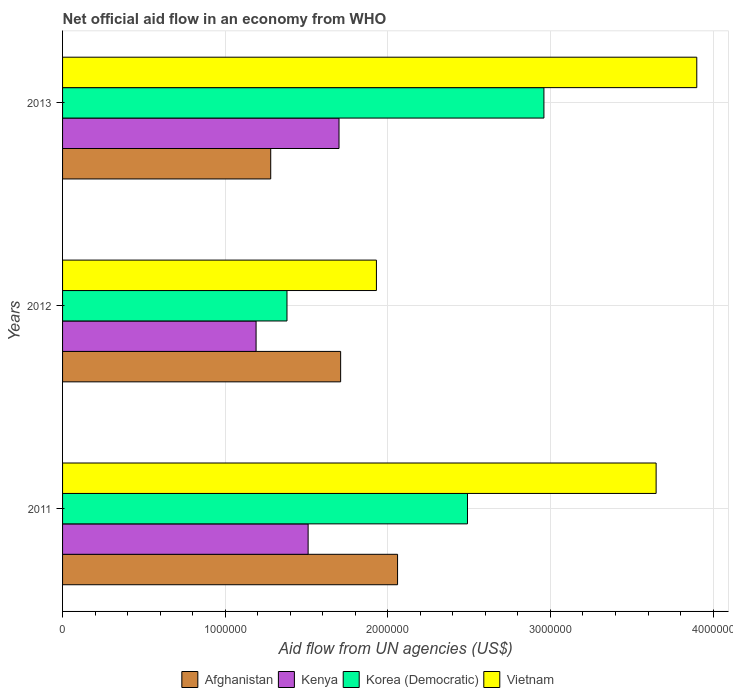How many groups of bars are there?
Make the answer very short. 3. In how many cases, is the number of bars for a given year not equal to the number of legend labels?
Give a very brief answer. 0. What is the net official aid flow in Kenya in 2013?
Offer a terse response. 1.70e+06. Across all years, what is the maximum net official aid flow in Korea (Democratic)?
Your response must be concise. 2.96e+06. Across all years, what is the minimum net official aid flow in Afghanistan?
Your answer should be very brief. 1.28e+06. What is the total net official aid flow in Korea (Democratic) in the graph?
Give a very brief answer. 6.83e+06. What is the difference between the net official aid flow in Korea (Democratic) in 2011 and the net official aid flow in Afghanistan in 2013?
Keep it short and to the point. 1.21e+06. What is the average net official aid flow in Kenya per year?
Ensure brevity in your answer.  1.47e+06. In the year 2013, what is the difference between the net official aid flow in Vietnam and net official aid flow in Kenya?
Offer a terse response. 2.20e+06. In how many years, is the net official aid flow in Korea (Democratic) greater than 2200000 US$?
Give a very brief answer. 2. What is the ratio of the net official aid flow in Afghanistan in 2011 to that in 2013?
Make the answer very short. 1.61. Is the difference between the net official aid flow in Vietnam in 2011 and 2013 greater than the difference between the net official aid flow in Kenya in 2011 and 2013?
Give a very brief answer. No. What is the difference between the highest and the lowest net official aid flow in Kenya?
Your response must be concise. 5.10e+05. In how many years, is the net official aid flow in Kenya greater than the average net official aid flow in Kenya taken over all years?
Give a very brief answer. 2. Is the sum of the net official aid flow in Kenya in 2012 and 2013 greater than the maximum net official aid flow in Afghanistan across all years?
Keep it short and to the point. Yes. Is it the case that in every year, the sum of the net official aid flow in Korea (Democratic) and net official aid flow in Kenya is greater than the sum of net official aid flow in Afghanistan and net official aid flow in Vietnam?
Offer a terse response. No. What does the 3rd bar from the top in 2013 represents?
Provide a succinct answer. Kenya. What does the 4th bar from the bottom in 2011 represents?
Provide a short and direct response. Vietnam. Are the values on the major ticks of X-axis written in scientific E-notation?
Your response must be concise. No. Where does the legend appear in the graph?
Give a very brief answer. Bottom center. How many legend labels are there?
Give a very brief answer. 4. What is the title of the graph?
Offer a terse response. Net official aid flow in an economy from WHO. Does "Serbia" appear as one of the legend labels in the graph?
Your answer should be compact. No. What is the label or title of the X-axis?
Offer a terse response. Aid flow from UN agencies (US$). What is the label or title of the Y-axis?
Provide a succinct answer. Years. What is the Aid flow from UN agencies (US$) of Afghanistan in 2011?
Your answer should be compact. 2.06e+06. What is the Aid flow from UN agencies (US$) of Kenya in 2011?
Provide a succinct answer. 1.51e+06. What is the Aid flow from UN agencies (US$) of Korea (Democratic) in 2011?
Your answer should be compact. 2.49e+06. What is the Aid flow from UN agencies (US$) of Vietnam in 2011?
Provide a short and direct response. 3.65e+06. What is the Aid flow from UN agencies (US$) in Afghanistan in 2012?
Your answer should be very brief. 1.71e+06. What is the Aid flow from UN agencies (US$) in Kenya in 2012?
Make the answer very short. 1.19e+06. What is the Aid flow from UN agencies (US$) in Korea (Democratic) in 2012?
Offer a terse response. 1.38e+06. What is the Aid flow from UN agencies (US$) in Vietnam in 2012?
Offer a very short reply. 1.93e+06. What is the Aid flow from UN agencies (US$) of Afghanistan in 2013?
Make the answer very short. 1.28e+06. What is the Aid flow from UN agencies (US$) in Kenya in 2013?
Your response must be concise. 1.70e+06. What is the Aid flow from UN agencies (US$) of Korea (Democratic) in 2013?
Your answer should be very brief. 2.96e+06. What is the Aid flow from UN agencies (US$) in Vietnam in 2013?
Provide a short and direct response. 3.90e+06. Across all years, what is the maximum Aid flow from UN agencies (US$) in Afghanistan?
Provide a succinct answer. 2.06e+06. Across all years, what is the maximum Aid flow from UN agencies (US$) of Kenya?
Your answer should be compact. 1.70e+06. Across all years, what is the maximum Aid flow from UN agencies (US$) in Korea (Democratic)?
Ensure brevity in your answer.  2.96e+06. Across all years, what is the maximum Aid flow from UN agencies (US$) of Vietnam?
Give a very brief answer. 3.90e+06. Across all years, what is the minimum Aid flow from UN agencies (US$) of Afghanistan?
Offer a terse response. 1.28e+06. Across all years, what is the minimum Aid flow from UN agencies (US$) in Kenya?
Offer a very short reply. 1.19e+06. Across all years, what is the minimum Aid flow from UN agencies (US$) of Korea (Democratic)?
Give a very brief answer. 1.38e+06. Across all years, what is the minimum Aid flow from UN agencies (US$) of Vietnam?
Make the answer very short. 1.93e+06. What is the total Aid flow from UN agencies (US$) of Afghanistan in the graph?
Make the answer very short. 5.05e+06. What is the total Aid flow from UN agencies (US$) of Kenya in the graph?
Your answer should be very brief. 4.40e+06. What is the total Aid flow from UN agencies (US$) of Korea (Democratic) in the graph?
Offer a terse response. 6.83e+06. What is the total Aid flow from UN agencies (US$) of Vietnam in the graph?
Your answer should be compact. 9.48e+06. What is the difference between the Aid flow from UN agencies (US$) in Korea (Democratic) in 2011 and that in 2012?
Offer a terse response. 1.11e+06. What is the difference between the Aid flow from UN agencies (US$) in Vietnam in 2011 and that in 2012?
Ensure brevity in your answer.  1.72e+06. What is the difference between the Aid flow from UN agencies (US$) in Afghanistan in 2011 and that in 2013?
Your answer should be very brief. 7.80e+05. What is the difference between the Aid flow from UN agencies (US$) of Kenya in 2011 and that in 2013?
Your answer should be very brief. -1.90e+05. What is the difference between the Aid flow from UN agencies (US$) of Korea (Democratic) in 2011 and that in 2013?
Ensure brevity in your answer.  -4.70e+05. What is the difference between the Aid flow from UN agencies (US$) in Vietnam in 2011 and that in 2013?
Make the answer very short. -2.50e+05. What is the difference between the Aid flow from UN agencies (US$) of Kenya in 2012 and that in 2013?
Ensure brevity in your answer.  -5.10e+05. What is the difference between the Aid flow from UN agencies (US$) of Korea (Democratic) in 2012 and that in 2013?
Keep it short and to the point. -1.58e+06. What is the difference between the Aid flow from UN agencies (US$) of Vietnam in 2012 and that in 2013?
Offer a terse response. -1.97e+06. What is the difference between the Aid flow from UN agencies (US$) of Afghanistan in 2011 and the Aid flow from UN agencies (US$) of Kenya in 2012?
Provide a short and direct response. 8.70e+05. What is the difference between the Aid flow from UN agencies (US$) of Afghanistan in 2011 and the Aid flow from UN agencies (US$) of Korea (Democratic) in 2012?
Provide a succinct answer. 6.80e+05. What is the difference between the Aid flow from UN agencies (US$) in Afghanistan in 2011 and the Aid flow from UN agencies (US$) in Vietnam in 2012?
Give a very brief answer. 1.30e+05. What is the difference between the Aid flow from UN agencies (US$) in Kenya in 2011 and the Aid flow from UN agencies (US$) in Vietnam in 2012?
Your answer should be very brief. -4.20e+05. What is the difference between the Aid flow from UN agencies (US$) in Korea (Democratic) in 2011 and the Aid flow from UN agencies (US$) in Vietnam in 2012?
Your answer should be very brief. 5.60e+05. What is the difference between the Aid flow from UN agencies (US$) in Afghanistan in 2011 and the Aid flow from UN agencies (US$) in Korea (Democratic) in 2013?
Offer a terse response. -9.00e+05. What is the difference between the Aid flow from UN agencies (US$) in Afghanistan in 2011 and the Aid flow from UN agencies (US$) in Vietnam in 2013?
Give a very brief answer. -1.84e+06. What is the difference between the Aid flow from UN agencies (US$) of Kenya in 2011 and the Aid flow from UN agencies (US$) of Korea (Democratic) in 2013?
Ensure brevity in your answer.  -1.45e+06. What is the difference between the Aid flow from UN agencies (US$) in Kenya in 2011 and the Aid flow from UN agencies (US$) in Vietnam in 2013?
Offer a terse response. -2.39e+06. What is the difference between the Aid flow from UN agencies (US$) in Korea (Democratic) in 2011 and the Aid flow from UN agencies (US$) in Vietnam in 2013?
Ensure brevity in your answer.  -1.41e+06. What is the difference between the Aid flow from UN agencies (US$) of Afghanistan in 2012 and the Aid flow from UN agencies (US$) of Korea (Democratic) in 2013?
Give a very brief answer. -1.25e+06. What is the difference between the Aid flow from UN agencies (US$) in Afghanistan in 2012 and the Aid flow from UN agencies (US$) in Vietnam in 2013?
Provide a succinct answer. -2.19e+06. What is the difference between the Aid flow from UN agencies (US$) of Kenya in 2012 and the Aid flow from UN agencies (US$) of Korea (Democratic) in 2013?
Provide a short and direct response. -1.77e+06. What is the difference between the Aid flow from UN agencies (US$) of Kenya in 2012 and the Aid flow from UN agencies (US$) of Vietnam in 2013?
Ensure brevity in your answer.  -2.71e+06. What is the difference between the Aid flow from UN agencies (US$) of Korea (Democratic) in 2012 and the Aid flow from UN agencies (US$) of Vietnam in 2013?
Make the answer very short. -2.52e+06. What is the average Aid flow from UN agencies (US$) in Afghanistan per year?
Give a very brief answer. 1.68e+06. What is the average Aid flow from UN agencies (US$) in Kenya per year?
Ensure brevity in your answer.  1.47e+06. What is the average Aid flow from UN agencies (US$) of Korea (Democratic) per year?
Provide a succinct answer. 2.28e+06. What is the average Aid flow from UN agencies (US$) in Vietnam per year?
Your response must be concise. 3.16e+06. In the year 2011, what is the difference between the Aid flow from UN agencies (US$) of Afghanistan and Aid flow from UN agencies (US$) of Kenya?
Your answer should be very brief. 5.50e+05. In the year 2011, what is the difference between the Aid flow from UN agencies (US$) in Afghanistan and Aid flow from UN agencies (US$) in Korea (Democratic)?
Provide a short and direct response. -4.30e+05. In the year 2011, what is the difference between the Aid flow from UN agencies (US$) of Afghanistan and Aid flow from UN agencies (US$) of Vietnam?
Your answer should be compact. -1.59e+06. In the year 2011, what is the difference between the Aid flow from UN agencies (US$) of Kenya and Aid flow from UN agencies (US$) of Korea (Democratic)?
Make the answer very short. -9.80e+05. In the year 2011, what is the difference between the Aid flow from UN agencies (US$) of Kenya and Aid flow from UN agencies (US$) of Vietnam?
Offer a terse response. -2.14e+06. In the year 2011, what is the difference between the Aid flow from UN agencies (US$) of Korea (Democratic) and Aid flow from UN agencies (US$) of Vietnam?
Your answer should be compact. -1.16e+06. In the year 2012, what is the difference between the Aid flow from UN agencies (US$) in Afghanistan and Aid flow from UN agencies (US$) in Kenya?
Give a very brief answer. 5.20e+05. In the year 2012, what is the difference between the Aid flow from UN agencies (US$) in Afghanistan and Aid flow from UN agencies (US$) in Vietnam?
Your answer should be compact. -2.20e+05. In the year 2012, what is the difference between the Aid flow from UN agencies (US$) in Kenya and Aid flow from UN agencies (US$) in Vietnam?
Provide a short and direct response. -7.40e+05. In the year 2012, what is the difference between the Aid flow from UN agencies (US$) in Korea (Democratic) and Aid flow from UN agencies (US$) in Vietnam?
Make the answer very short. -5.50e+05. In the year 2013, what is the difference between the Aid flow from UN agencies (US$) of Afghanistan and Aid flow from UN agencies (US$) of Kenya?
Offer a terse response. -4.20e+05. In the year 2013, what is the difference between the Aid flow from UN agencies (US$) in Afghanistan and Aid flow from UN agencies (US$) in Korea (Democratic)?
Provide a short and direct response. -1.68e+06. In the year 2013, what is the difference between the Aid flow from UN agencies (US$) of Afghanistan and Aid flow from UN agencies (US$) of Vietnam?
Offer a very short reply. -2.62e+06. In the year 2013, what is the difference between the Aid flow from UN agencies (US$) in Kenya and Aid flow from UN agencies (US$) in Korea (Democratic)?
Your answer should be compact. -1.26e+06. In the year 2013, what is the difference between the Aid flow from UN agencies (US$) in Kenya and Aid flow from UN agencies (US$) in Vietnam?
Make the answer very short. -2.20e+06. In the year 2013, what is the difference between the Aid flow from UN agencies (US$) of Korea (Democratic) and Aid flow from UN agencies (US$) of Vietnam?
Offer a very short reply. -9.40e+05. What is the ratio of the Aid flow from UN agencies (US$) of Afghanistan in 2011 to that in 2012?
Give a very brief answer. 1.2. What is the ratio of the Aid flow from UN agencies (US$) in Kenya in 2011 to that in 2012?
Make the answer very short. 1.27. What is the ratio of the Aid flow from UN agencies (US$) of Korea (Democratic) in 2011 to that in 2012?
Offer a terse response. 1.8. What is the ratio of the Aid flow from UN agencies (US$) of Vietnam in 2011 to that in 2012?
Keep it short and to the point. 1.89. What is the ratio of the Aid flow from UN agencies (US$) of Afghanistan in 2011 to that in 2013?
Offer a terse response. 1.61. What is the ratio of the Aid flow from UN agencies (US$) in Kenya in 2011 to that in 2013?
Make the answer very short. 0.89. What is the ratio of the Aid flow from UN agencies (US$) in Korea (Democratic) in 2011 to that in 2013?
Make the answer very short. 0.84. What is the ratio of the Aid flow from UN agencies (US$) of Vietnam in 2011 to that in 2013?
Offer a terse response. 0.94. What is the ratio of the Aid flow from UN agencies (US$) of Afghanistan in 2012 to that in 2013?
Give a very brief answer. 1.34. What is the ratio of the Aid flow from UN agencies (US$) of Korea (Democratic) in 2012 to that in 2013?
Make the answer very short. 0.47. What is the ratio of the Aid flow from UN agencies (US$) in Vietnam in 2012 to that in 2013?
Give a very brief answer. 0.49. What is the difference between the highest and the second highest Aid flow from UN agencies (US$) in Kenya?
Provide a succinct answer. 1.90e+05. What is the difference between the highest and the second highest Aid flow from UN agencies (US$) of Vietnam?
Your response must be concise. 2.50e+05. What is the difference between the highest and the lowest Aid flow from UN agencies (US$) of Afghanistan?
Keep it short and to the point. 7.80e+05. What is the difference between the highest and the lowest Aid flow from UN agencies (US$) of Kenya?
Provide a short and direct response. 5.10e+05. What is the difference between the highest and the lowest Aid flow from UN agencies (US$) of Korea (Democratic)?
Your answer should be very brief. 1.58e+06. What is the difference between the highest and the lowest Aid flow from UN agencies (US$) of Vietnam?
Provide a short and direct response. 1.97e+06. 